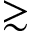<formula> <loc_0><loc_0><loc_500><loc_500>\gtrsim</formula> 